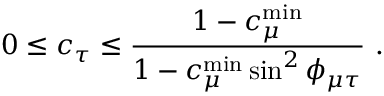<formula> <loc_0><loc_0><loc_500><loc_500>0 \leq c _ { \tau } \leq \frac { 1 - c _ { \mu } ^ { \min } } { 1 - c _ { \mu } ^ { \min } \sin ^ { 2 } \phi _ { \mu \tau } } .</formula> 